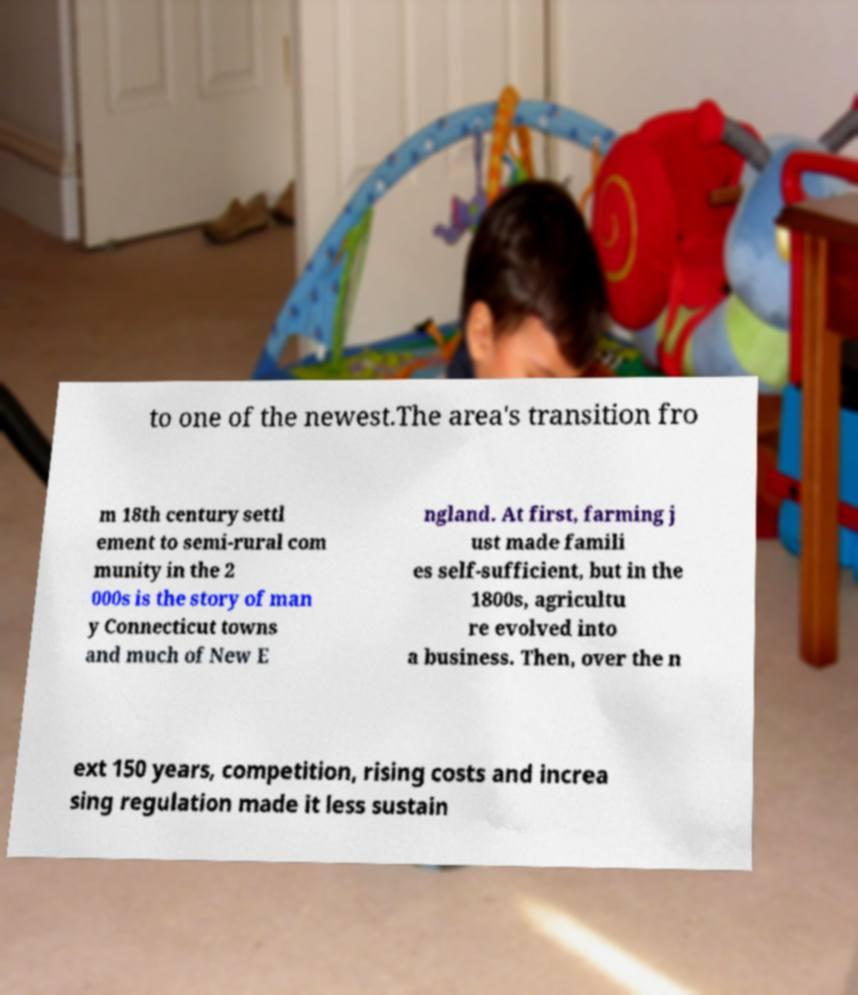Can you read and provide the text displayed in the image?This photo seems to have some interesting text. Can you extract and type it out for me? to one of the newest.The area's transition fro m 18th century settl ement to semi-rural com munity in the 2 000s is the story of man y Connecticut towns and much of New E ngland. At first, farming j ust made famili es self-sufficient, but in the 1800s, agricultu re evolved into a business. Then, over the n ext 150 years, competition, rising costs and increa sing regulation made it less sustain 